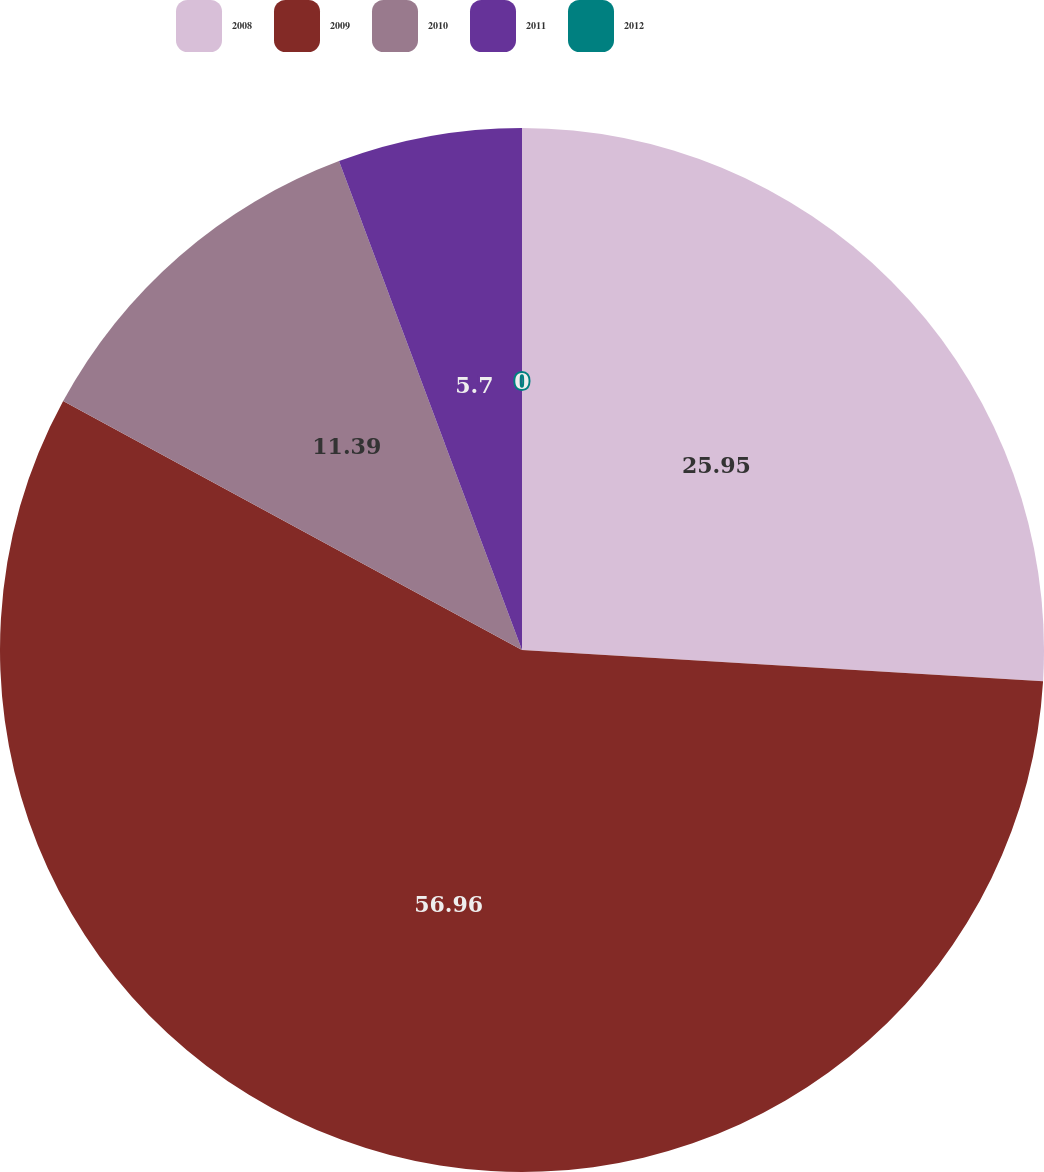<chart> <loc_0><loc_0><loc_500><loc_500><pie_chart><fcel>2008<fcel>2009<fcel>2010<fcel>2011<fcel>2012<nl><fcel>25.95%<fcel>56.96%<fcel>11.39%<fcel>5.7%<fcel>0.0%<nl></chart> 